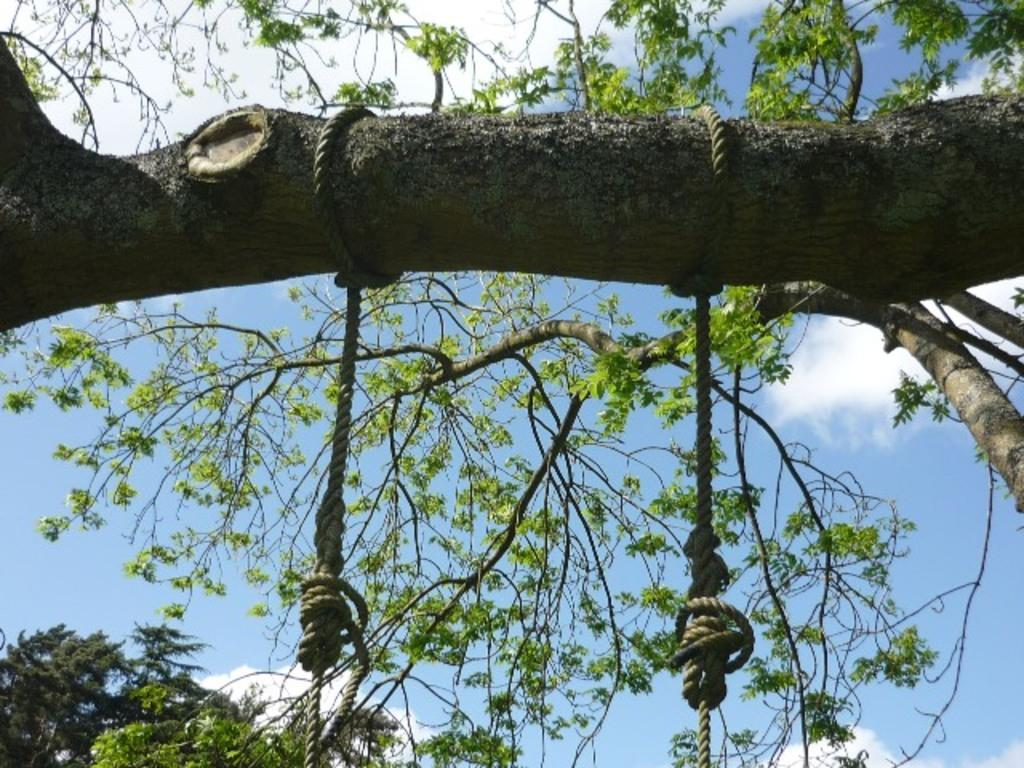What objects can be seen hanging from a branch in the image? There are two ropes on a branch of a tree in the image. What can be seen in the background behind the branch? Leaves and branches are visible behind the branch in the image. What type of mask is the crow wearing in the image? There is no crow or mask present in the image. Can you describe the flight pattern of the birds in the image? There are no birds visible in the image, so it is not possible to describe their flight pattern. 